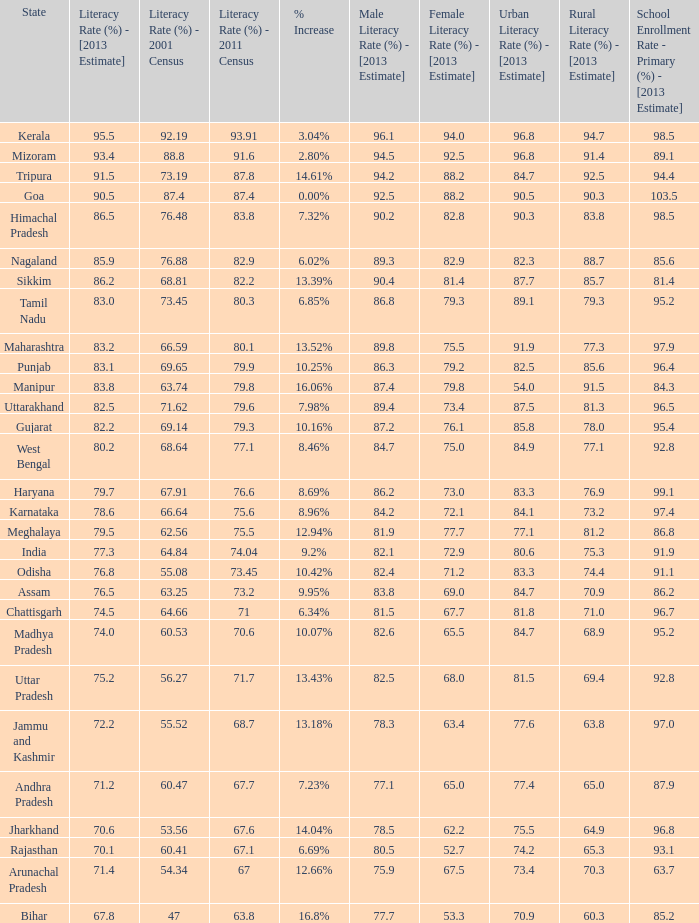What is the average estimated 2013 literacy rate for the states that had a literacy rate of 68.81% in the 2001 census and a literacy rate higher than 79.6% in the 2011 census? 86.2. 